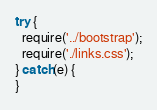Convert code to text. <code><loc_0><loc_0><loc_500><loc_500><_JavaScript_>try {
  require('../bootstrap');
  require('./links.css');
} catch(e) {
}
</code> 